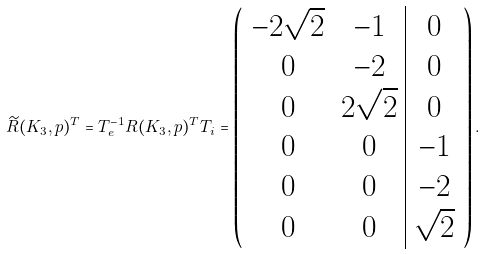<formula> <loc_0><loc_0><loc_500><loc_500>\widetilde { R } ( K _ { 3 } , p ) ^ { T } = T _ { e } ^ { - 1 } R ( K _ { 3 } , p ) ^ { T } T _ { i } = \left ( \begin{array} { c c | c } - 2 \sqrt { 2 } & - 1 & 0 \\ 0 & - 2 & 0 \\ 0 & 2 \sqrt { 2 } & 0 \\ 0 & 0 & - 1 \\ 0 & 0 & - 2 \\ 0 & 0 & \sqrt { 2 } \end{array} \right ) .</formula> 